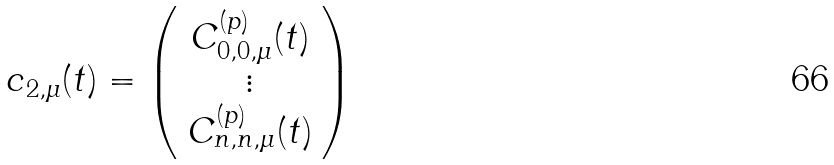<formula> <loc_0><loc_0><loc_500><loc_500>{ c } _ { 2 , \mu } ( t ) = \left ( \begin{array} { c } C ^ { ( p ) } _ { 0 , 0 , \mu } ( t ) \\ \vdots \\ C ^ { ( p ) } _ { n , n , \mu } ( t ) \end{array} \right )</formula> 